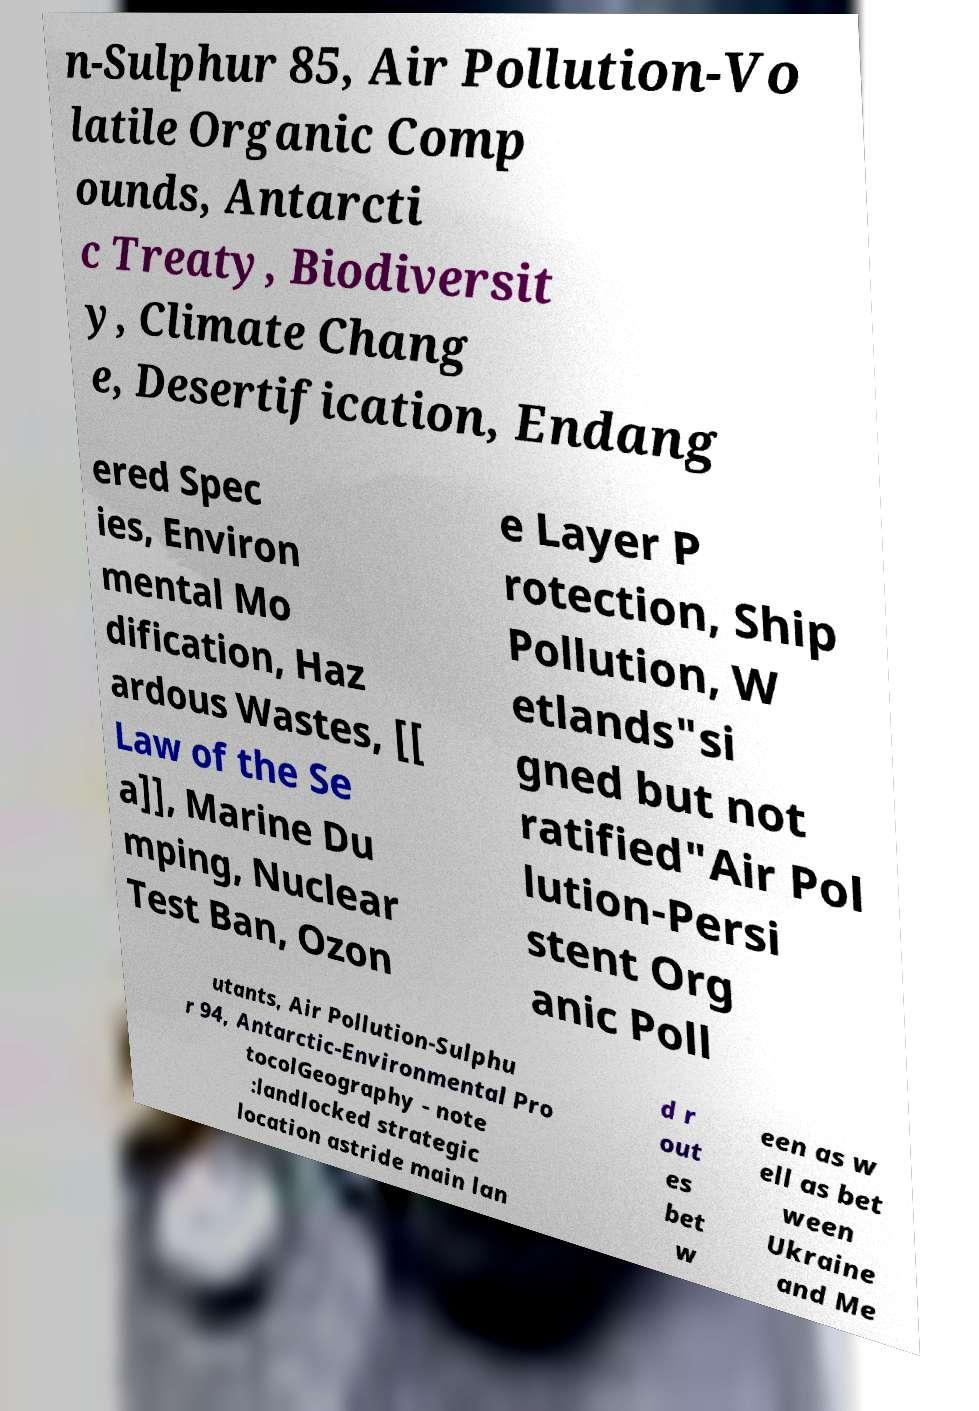Can you accurately transcribe the text from the provided image for me? n-Sulphur 85, Air Pollution-Vo latile Organic Comp ounds, Antarcti c Treaty, Biodiversit y, Climate Chang e, Desertification, Endang ered Spec ies, Environ mental Mo dification, Haz ardous Wastes, [[ Law of the Se a]], Marine Du mping, Nuclear Test Ban, Ozon e Layer P rotection, Ship Pollution, W etlands"si gned but not ratified"Air Pol lution-Persi stent Org anic Poll utants, Air Pollution-Sulphu r 94, Antarctic-Environmental Pro tocolGeography - note :landlocked strategic location astride main lan d r out es bet w een as w ell as bet ween Ukraine and Me 